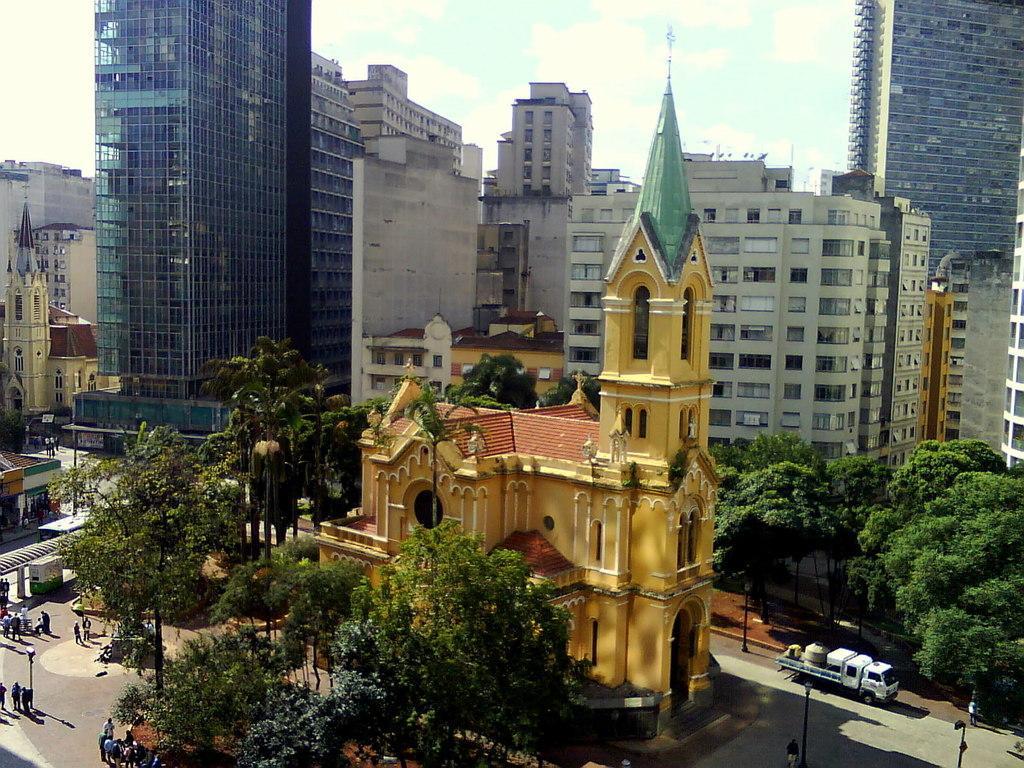In one or two sentences, can you explain what this image depicts? In this image there are buildings and trees. At the bottom there are vehicles on the road and we can see people. There are poles. In the background there is sky. 